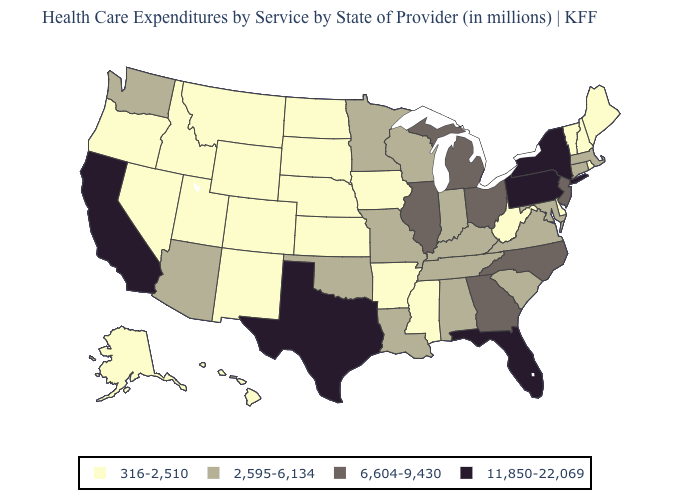What is the value of South Carolina?
Write a very short answer. 2,595-6,134. What is the value of New Mexico?
Write a very short answer. 316-2,510. Does the map have missing data?
Short answer required. No. What is the value of South Dakota?
Give a very brief answer. 316-2,510. Name the states that have a value in the range 2,595-6,134?
Short answer required. Alabama, Arizona, Connecticut, Indiana, Kentucky, Louisiana, Maryland, Massachusetts, Minnesota, Missouri, Oklahoma, South Carolina, Tennessee, Virginia, Washington, Wisconsin. Does Wyoming have the highest value in the West?
Write a very short answer. No. Name the states that have a value in the range 11,850-22,069?
Concise answer only. California, Florida, New York, Pennsylvania, Texas. Which states have the lowest value in the USA?
Give a very brief answer. Alaska, Arkansas, Colorado, Delaware, Hawaii, Idaho, Iowa, Kansas, Maine, Mississippi, Montana, Nebraska, Nevada, New Hampshire, New Mexico, North Dakota, Oregon, Rhode Island, South Dakota, Utah, Vermont, West Virginia, Wyoming. Which states have the highest value in the USA?
Short answer required. California, Florida, New York, Pennsylvania, Texas. Name the states that have a value in the range 316-2,510?
Write a very short answer. Alaska, Arkansas, Colorado, Delaware, Hawaii, Idaho, Iowa, Kansas, Maine, Mississippi, Montana, Nebraska, Nevada, New Hampshire, New Mexico, North Dakota, Oregon, Rhode Island, South Dakota, Utah, Vermont, West Virginia, Wyoming. What is the value of Maryland?
Short answer required. 2,595-6,134. What is the value of Pennsylvania?
Write a very short answer. 11,850-22,069. Does Maryland have the lowest value in the USA?
Write a very short answer. No. Among the states that border Louisiana , does Texas have the lowest value?
Quick response, please. No. 